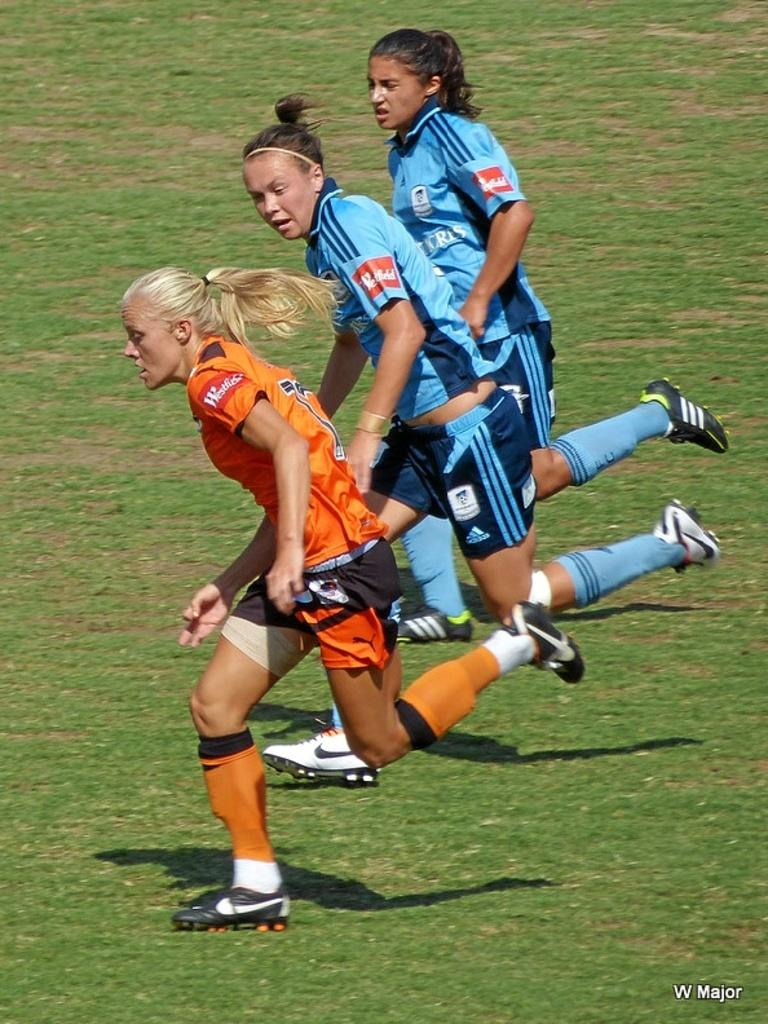How many people are in the image? There are three women in the image. What are the women doing in the image? The women are running. What type of surface are the women running on? The women are running on the grass. What type of basketball skills can be seen in the image? There is no basketball present in the image, so it's not possible to determine any basketball skills. 